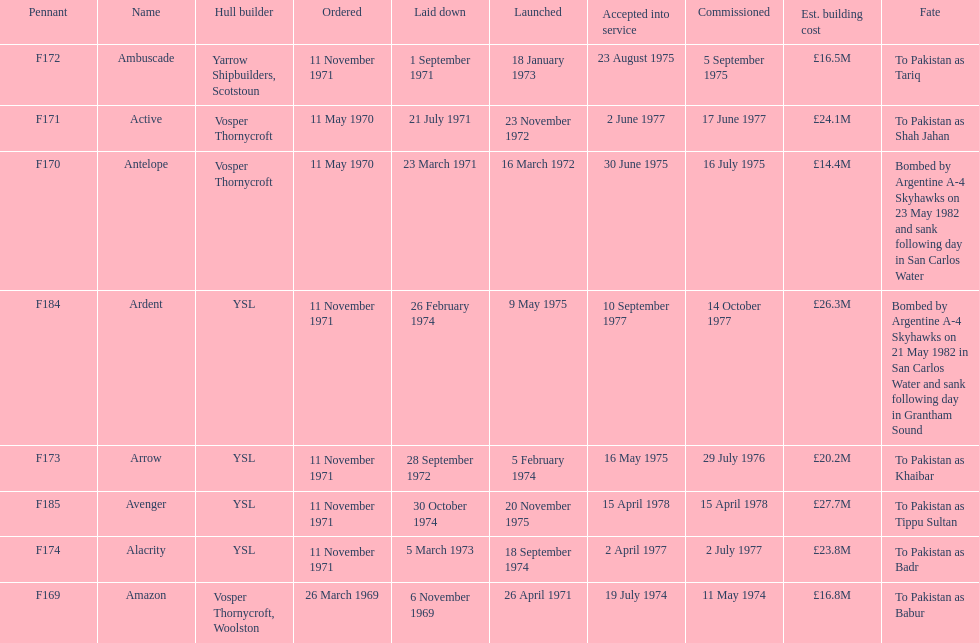Tell me the number of ships that went to pakistan. 6. Could you parse the entire table? {'header': ['Pennant', 'Name', 'Hull builder', 'Ordered', 'Laid down', 'Launched', 'Accepted into service', 'Commissioned', 'Est. building cost', 'Fate'], 'rows': [['F172', 'Ambuscade', 'Yarrow Shipbuilders, Scotstoun', '11 November 1971', '1 September 1971', '18 January 1973', '23 August 1975', '5 September 1975', '£16.5M', 'To Pakistan as Tariq'], ['F171', 'Active', 'Vosper Thornycroft', '11 May 1970', '21 July 1971', '23 November 1972', '2 June 1977', '17 June 1977', '£24.1M', 'To Pakistan as Shah Jahan'], ['F170', 'Antelope', 'Vosper Thornycroft', '11 May 1970', '23 March 1971', '16 March 1972', '30 June 1975', '16 July 1975', '£14.4M', 'Bombed by Argentine A-4 Skyhawks on 23 May 1982 and sank following day in San Carlos Water'], ['F184', 'Ardent', 'YSL', '11 November 1971', '26 February 1974', '9 May 1975', '10 September 1977', '14 October 1977', '£26.3M', 'Bombed by Argentine A-4 Skyhawks on 21 May 1982 in San Carlos Water and sank following day in Grantham Sound'], ['F173', 'Arrow', 'YSL', '11 November 1971', '28 September 1972', '5 February 1974', '16 May 1975', '29 July 1976', '£20.2M', 'To Pakistan as Khaibar'], ['F185', 'Avenger', 'YSL', '11 November 1971', '30 October 1974', '20 November 1975', '15 April 1978', '15 April 1978', '£27.7M', 'To Pakistan as Tippu Sultan'], ['F174', 'Alacrity', 'YSL', '11 November 1971', '5 March 1973', '18 September 1974', '2 April 1977', '2 July 1977', '£23.8M', 'To Pakistan as Badr'], ['F169', 'Amazon', 'Vosper Thornycroft, Woolston', '26 March 1969', '6 November 1969', '26 April 1971', '19 July 1974', '11 May 1974', '£16.8M', 'To Pakistan as Babur']]} 